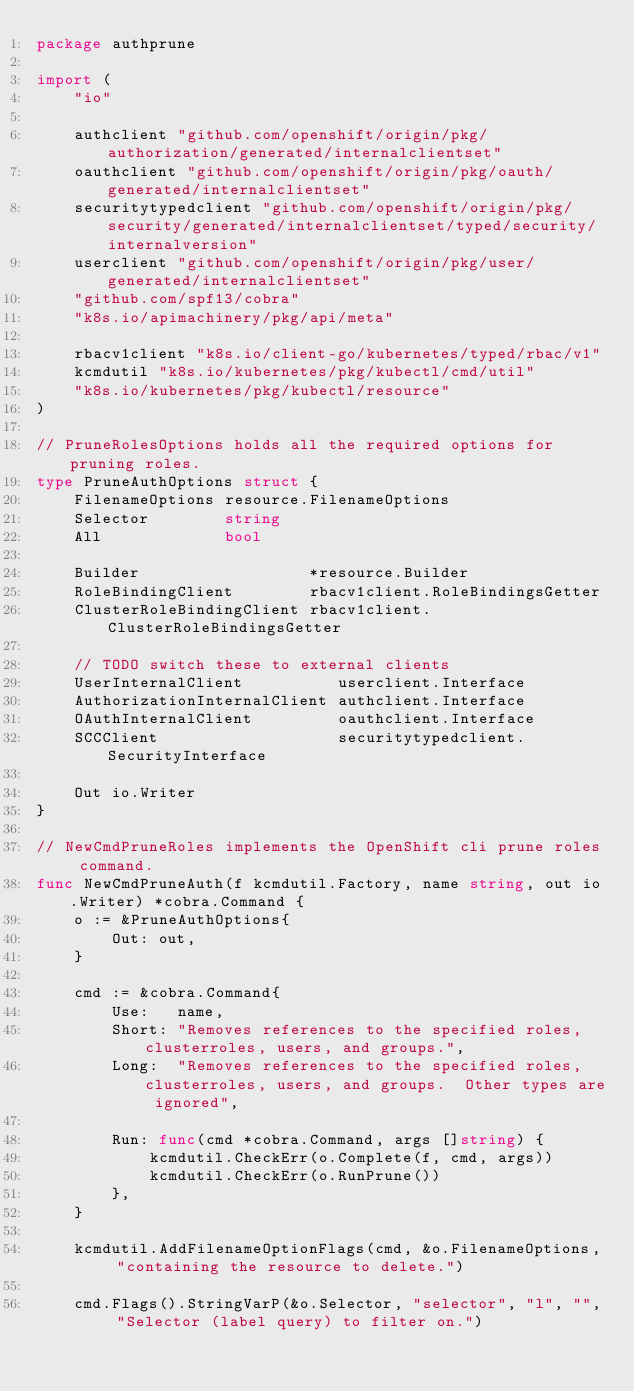<code> <loc_0><loc_0><loc_500><loc_500><_Go_>package authprune

import (
	"io"

	authclient "github.com/openshift/origin/pkg/authorization/generated/internalclientset"
	oauthclient "github.com/openshift/origin/pkg/oauth/generated/internalclientset"
	securitytypedclient "github.com/openshift/origin/pkg/security/generated/internalclientset/typed/security/internalversion"
	userclient "github.com/openshift/origin/pkg/user/generated/internalclientset"
	"github.com/spf13/cobra"
	"k8s.io/apimachinery/pkg/api/meta"

	rbacv1client "k8s.io/client-go/kubernetes/typed/rbac/v1"
	kcmdutil "k8s.io/kubernetes/pkg/kubectl/cmd/util"
	"k8s.io/kubernetes/pkg/kubectl/resource"
)

// PruneRolesOptions holds all the required options for pruning roles.
type PruneAuthOptions struct {
	FilenameOptions resource.FilenameOptions
	Selector        string
	All             bool

	Builder                  *resource.Builder
	RoleBindingClient        rbacv1client.RoleBindingsGetter
	ClusterRoleBindingClient rbacv1client.ClusterRoleBindingsGetter

	// TODO switch these to external clients
	UserInternalClient          userclient.Interface
	AuthorizationInternalClient authclient.Interface
	OAuthInternalClient         oauthclient.Interface
	SCCClient                   securitytypedclient.SecurityInterface

	Out io.Writer
}

// NewCmdPruneRoles implements the OpenShift cli prune roles command.
func NewCmdPruneAuth(f kcmdutil.Factory, name string, out io.Writer) *cobra.Command {
	o := &PruneAuthOptions{
		Out: out,
	}

	cmd := &cobra.Command{
		Use:   name,
		Short: "Removes references to the specified roles, clusterroles, users, and groups.",
		Long:  "Removes references to the specified roles, clusterroles, users, and groups.  Other types are ignored",

		Run: func(cmd *cobra.Command, args []string) {
			kcmdutil.CheckErr(o.Complete(f, cmd, args))
			kcmdutil.CheckErr(o.RunPrune())
		},
	}

	kcmdutil.AddFilenameOptionFlags(cmd, &o.FilenameOptions, "containing the resource to delete.")

	cmd.Flags().StringVarP(&o.Selector, "selector", "l", "", "Selector (label query) to filter on.")</code> 